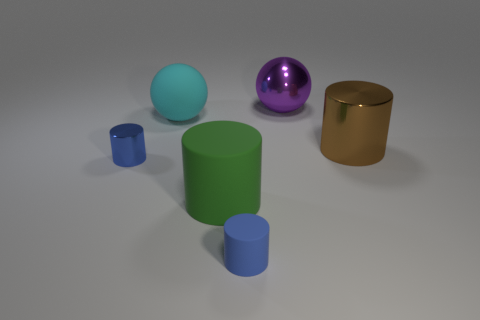How many other things are the same material as the green cylinder?
Your answer should be compact. 2. The purple ball is what size?
Your response must be concise. Large. Is there another green object of the same shape as the large green object?
Give a very brief answer. No. What number of things are large cyan rubber cylinders or large shiny objects behind the large brown cylinder?
Provide a succinct answer. 1. What color is the big metallic thing that is in front of the big purple metal thing?
Provide a succinct answer. Brown. There is a cyan matte ball on the left side of the purple ball; is its size the same as the shiny cylinder to the right of the green object?
Keep it short and to the point. Yes. Are there any other matte spheres of the same size as the cyan ball?
Your answer should be compact. No. What number of cyan matte things are left of the small cylinder left of the rubber ball?
Give a very brief answer. 0. What is the cyan object made of?
Give a very brief answer. Rubber. What number of rubber objects are behind the cyan rubber object?
Offer a very short reply. 0. 